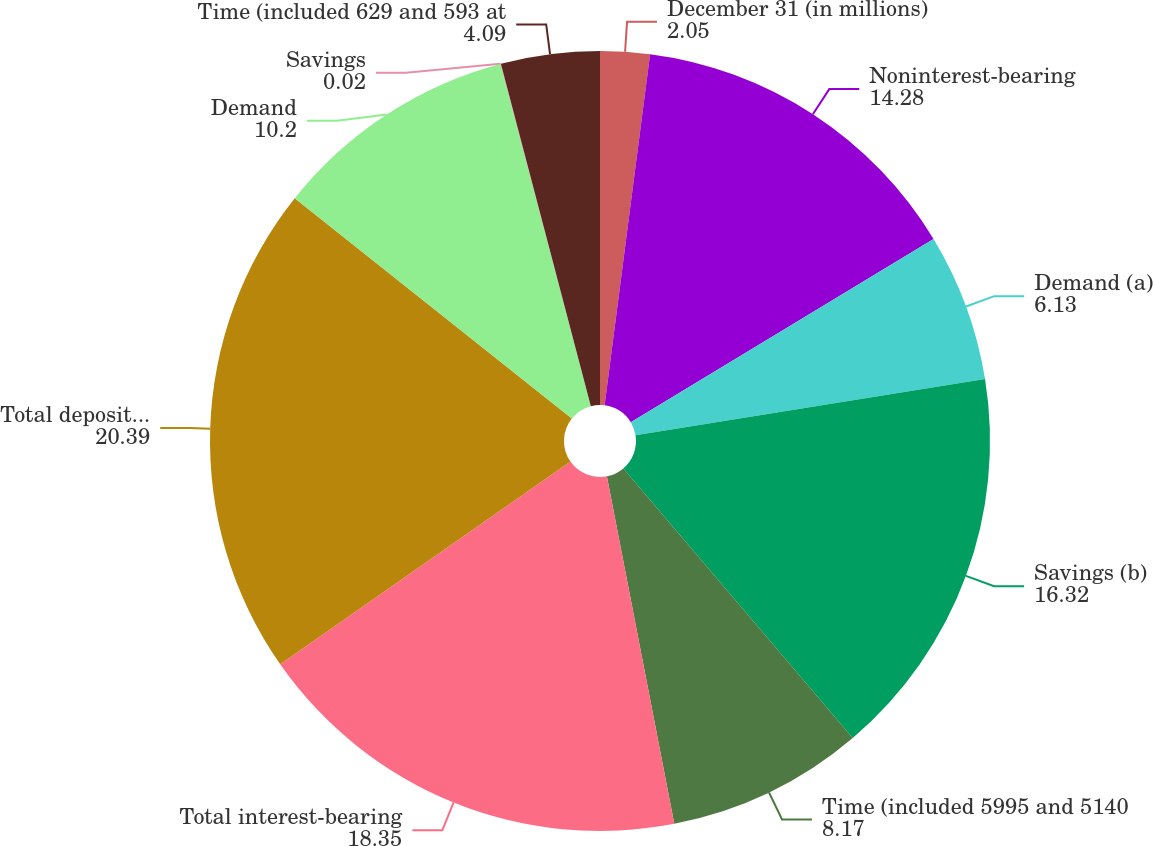Convert chart. <chart><loc_0><loc_0><loc_500><loc_500><pie_chart><fcel>December 31 (in millions)<fcel>Noninterest-bearing<fcel>Demand (a)<fcel>Savings (b)<fcel>Time (included 5995 and 5140<fcel>Total interest-bearing<fcel>Total deposits in US offices<fcel>Demand<fcel>Savings<fcel>Time (included 629 and 593 at<nl><fcel>2.05%<fcel>14.28%<fcel>6.13%<fcel>16.32%<fcel>8.17%<fcel>18.35%<fcel>20.39%<fcel>10.2%<fcel>0.02%<fcel>4.09%<nl></chart> 